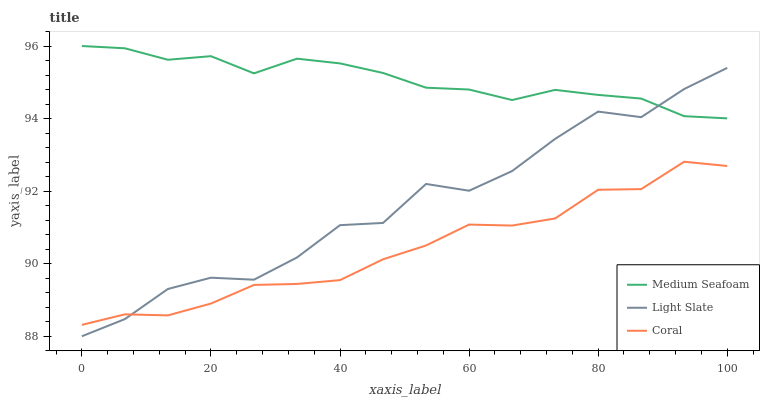Does Coral have the minimum area under the curve?
Answer yes or no. Yes. Does Medium Seafoam have the maximum area under the curve?
Answer yes or no. Yes. Does Medium Seafoam have the minimum area under the curve?
Answer yes or no. No. Does Coral have the maximum area under the curve?
Answer yes or no. No. Is Medium Seafoam the smoothest?
Answer yes or no. Yes. Is Light Slate the roughest?
Answer yes or no. Yes. Is Coral the smoothest?
Answer yes or no. No. Is Coral the roughest?
Answer yes or no. No. Does Light Slate have the lowest value?
Answer yes or no. Yes. Does Coral have the lowest value?
Answer yes or no. No. Does Medium Seafoam have the highest value?
Answer yes or no. Yes. Does Coral have the highest value?
Answer yes or no. No. Is Coral less than Medium Seafoam?
Answer yes or no. Yes. Is Medium Seafoam greater than Coral?
Answer yes or no. Yes. Does Light Slate intersect Medium Seafoam?
Answer yes or no. Yes. Is Light Slate less than Medium Seafoam?
Answer yes or no. No. Is Light Slate greater than Medium Seafoam?
Answer yes or no. No. Does Coral intersect Medium Seafoam?
Answer yes or no. No. 